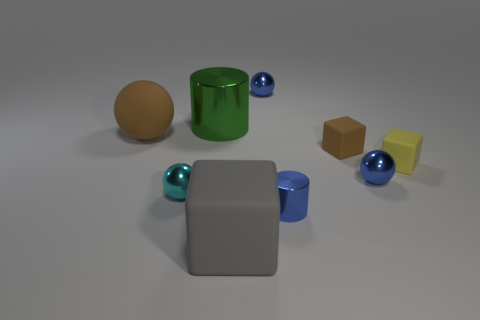Subtract all tiny brown cubes. How many cubes are left? 2 Subtract 1 cubes. How many cubes are left? 2 Add 1 green objects. How many objects exist? 10 Subtract all gray blocks. How many blocks are left? 2 Subtract all balls. How many objects are left? 5 Subtract 0 blue blocks. How many objects are left? 9 Subtract all yellow cylinders. Subtract all cyan cubes. How many cylinders are left? 2 Subtract all yellow cylinders. How many yellow blocks are left? 1 Subtract all brown shiny cubes. Subtract all brown rubber spheres. How many objects are left? 8 Add 7 yellow matte cubes. How many yellow matte cubes are left? 8 